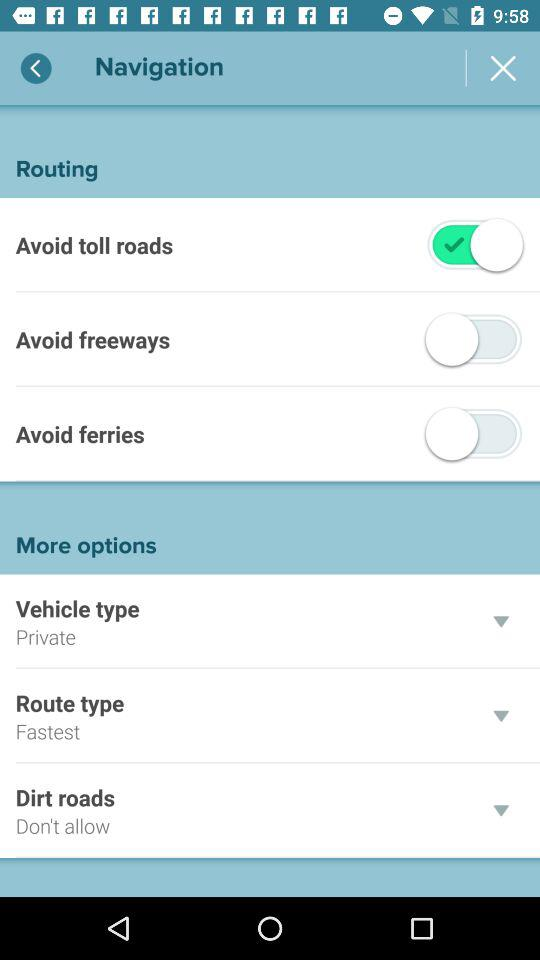How many switches are there in the routing options section?
Answer the question using a single word or phrase. 3 